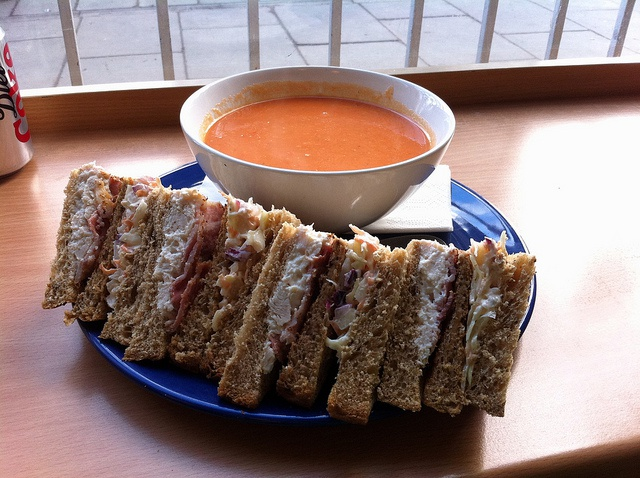Describe the objects in this image and their specific colors. I can see bowl in gray, salmon, and lightgray tones, sandwich in gray, black, and maroon tones, sandwich in gray, black, and maroon tones, sandwich in gray, black, and maroon tones, and sandwich in gray, black, and maroon tones in this image. 